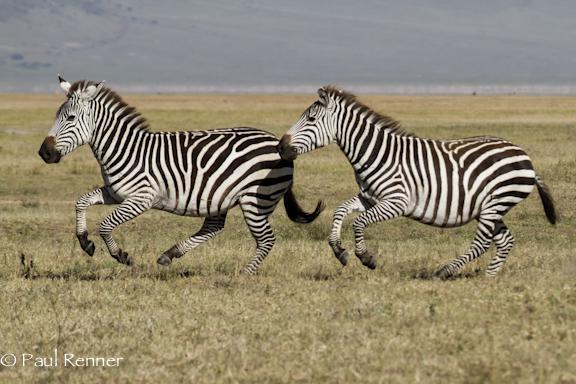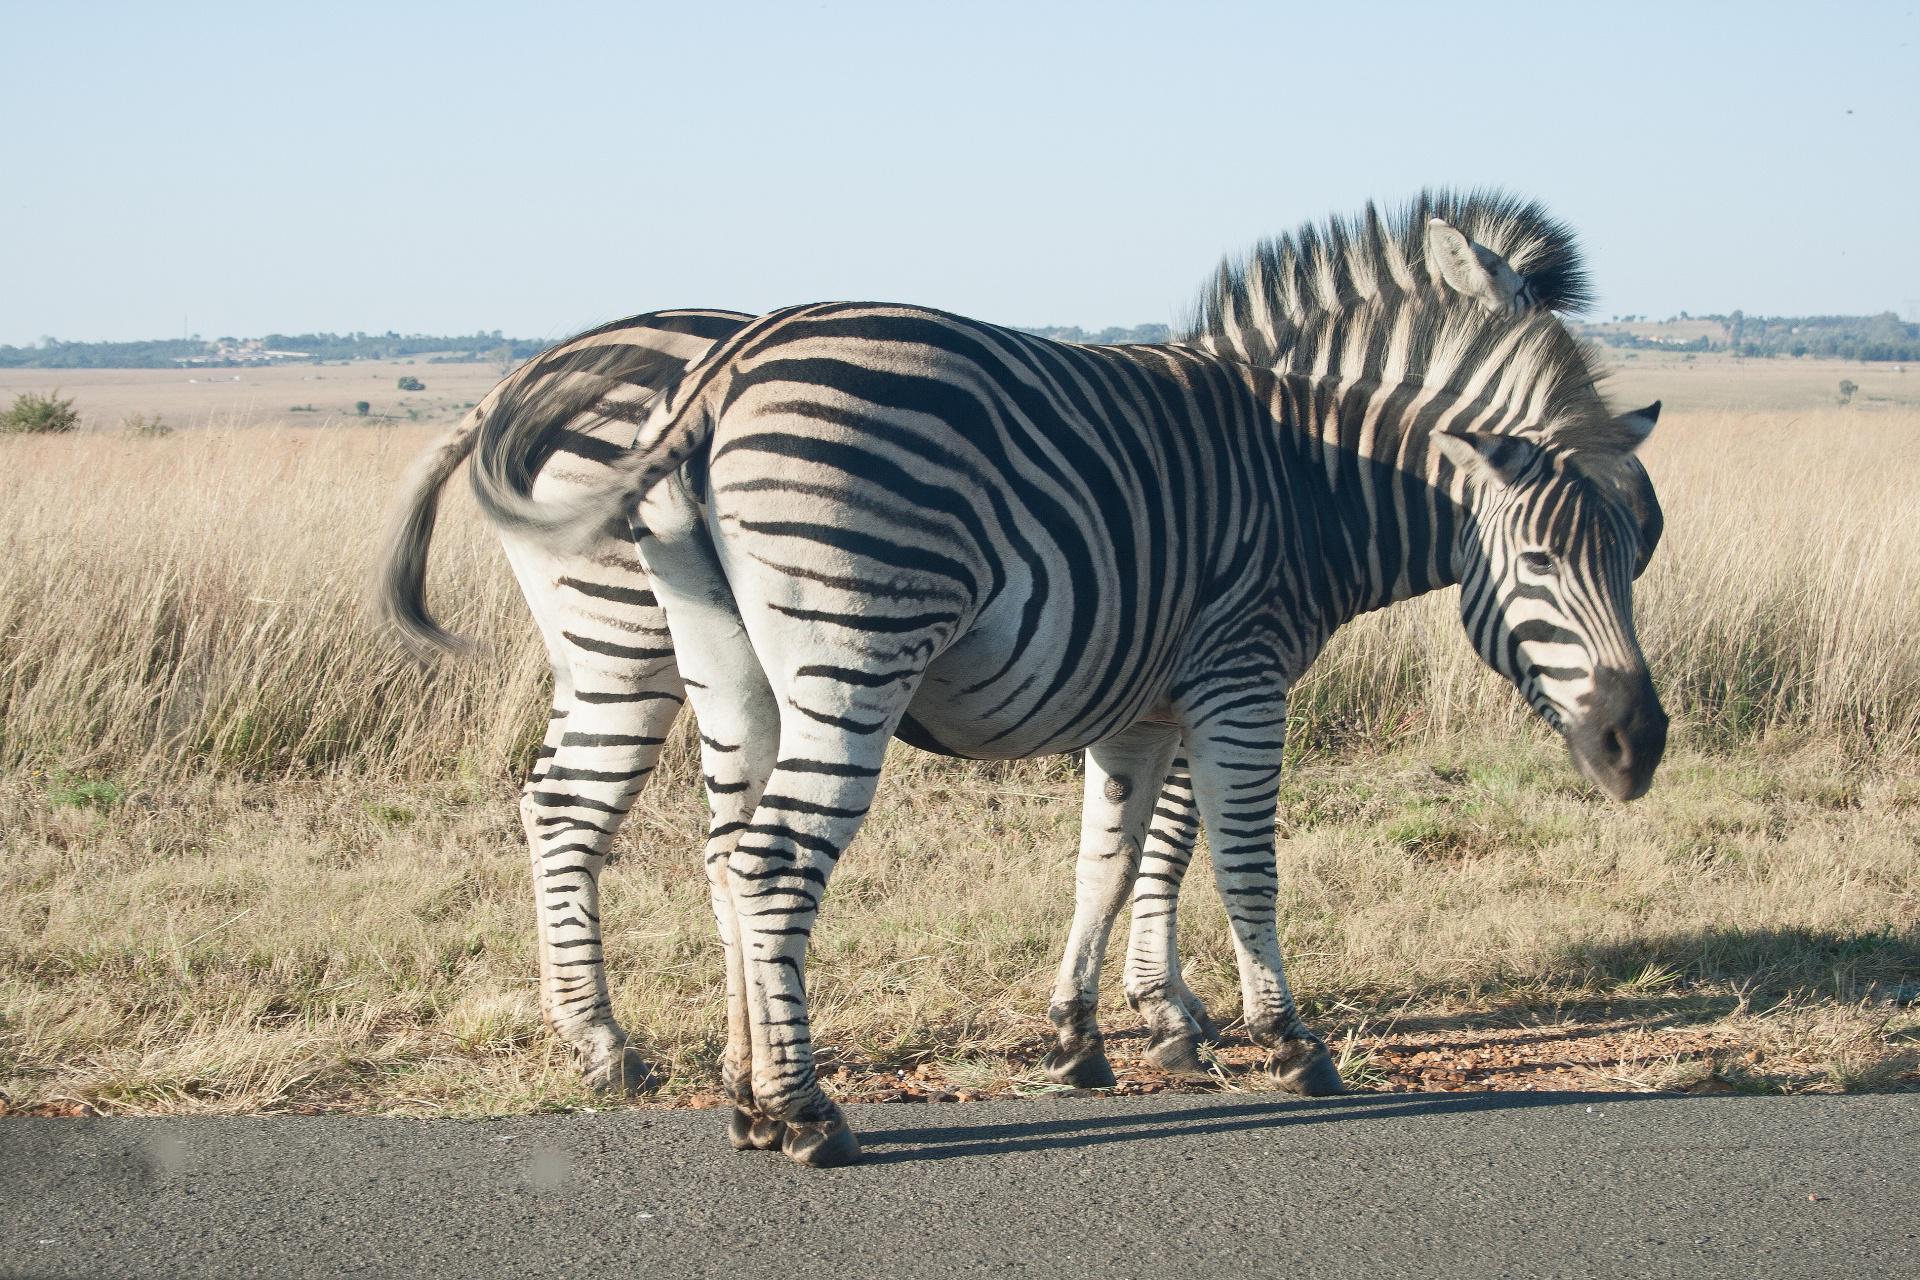The first image is the image on the left, the second image is the image on the right. Assess this claim about the two images: "The image on the right shows two zebras embracing each other with their heads.". Correct or not? Answer yes or no. No. 